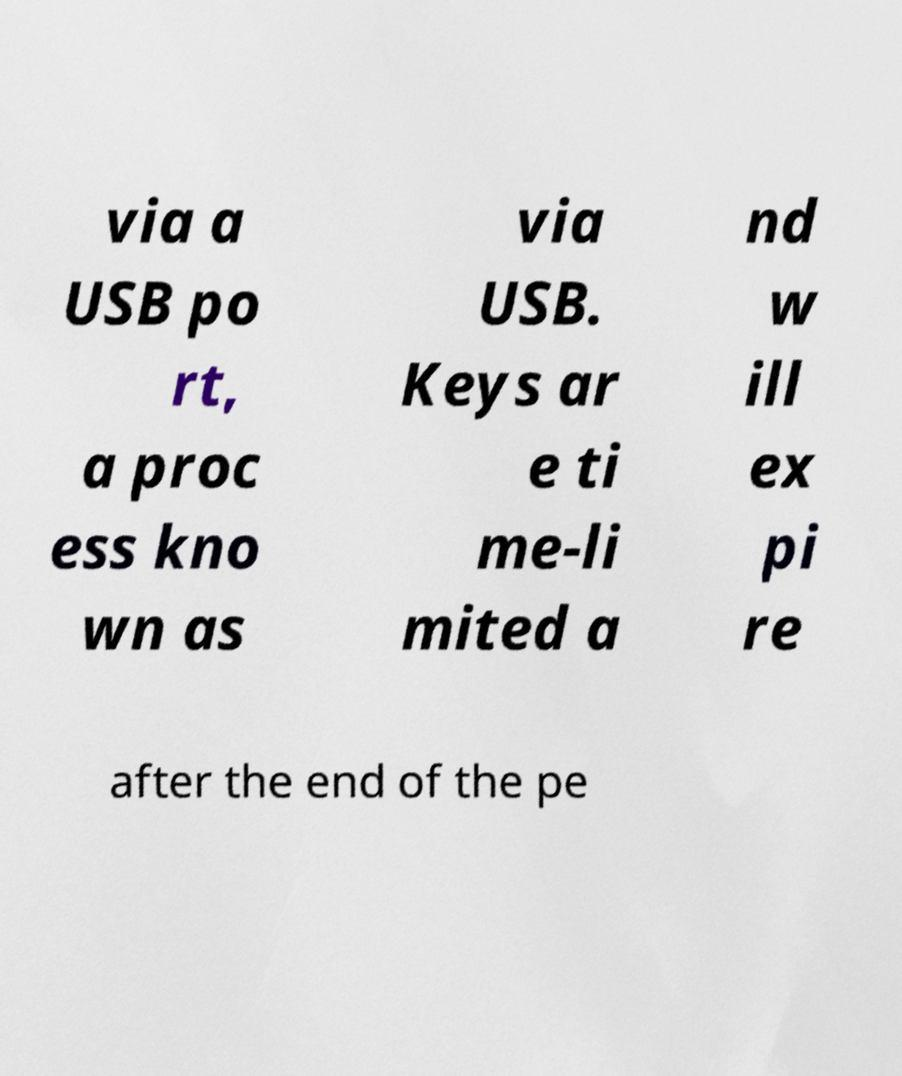Please identify and transcribe the text found in this image. via a USB po rt, a proc ess kno wn as via USB. Keys ar e ti me-li mited a nd w ill ex pi re after the end of the pe 